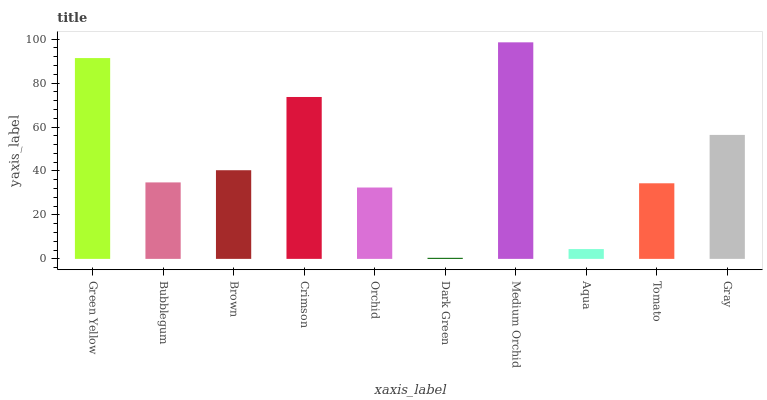Is Dark Green the minimum?
Answer yes or no. Yes. Is Medium Orchid the maximum?
Answer yes or no. Yes. Is Bubblegum the minimum?
Answer yes or no. No. Is Bubblegum the maximum?
Answer yes or no. No. Is Green Yellow greater than Bubblegum?
Answer yes or no. Yes. Is Bubblegum less than Green Yellow?
Answer yes or no. Yes. Is Bubblegum greater than Green Yellow?
Answer yes or no. No. Is Green Yellow less than Bubblegum?
Answer yes or no. No. Is Brown the high median?
Answer yes or no. Yes. Is Bubblegum the low median?
Answer yes or no. Yes. Is Bubblegum the high median?
Answer yes or no. No. Is Tomato the low median?
Answer yes or no. No. 